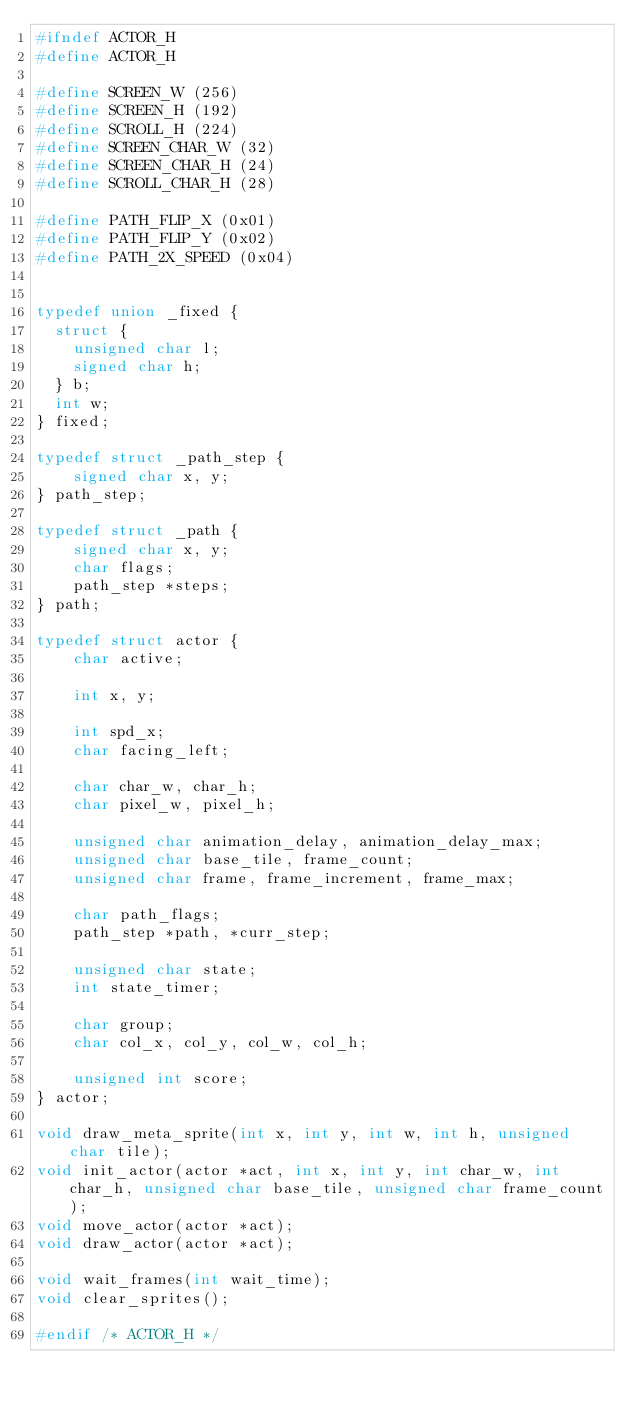<code> <loc_0><loc_0><loc_500><loc_500><_C_>#ifndef ACTOR_H
#define ACTOR_H

#define SCREEN_W (256)
#define SCREEN_H (192)
#define SCROLL_H (224)
#define SCREEN_CHAR_W (32)
#define SCREEN_CHAR_H (24)
#define SCROLL_CHAR_H (28)

#define PATH_FLIP_X (0x01)
#define PATH_FLIP_Y (0x02)
#define PATH_2X_SPEED (0x04)


typedef union _fixed {
  struct {
    unsigned char l;
    signed char h;
  } b;
  int w;
} fixed;

typedef struct _path_step {
	signed char x, y;
} path_step;

typedef struct _path {
	signed char x, y;
	char flags;
	path_step *steps;
} path;

typedef struct actor {
	char active;
	
	int x, y;
	
	int spd_x;
	char facing_left;
	
	char char_w, char_h;
	char pixel_w, pixel_h;
	
	unsigned char animation_delay, animation_delay_max;
	unsigned char base_tile, frame_count;
	unsigned char frame, frame_increment, frame_max;
	
	char path_flags;
	path_step *path, *curr_step;
	
	unsigned char state;
	int state_timer;
	
	char group;
	char col_x, col_y, col_w, col_h;
	
	unsigned int score;
} actor;

void draw_meta_sprite(int x, int y, int w, int h, unsigned char tile);
void init_actor(actor *act, int x, int y, int char_w, int char_h, unsigned char base_tile, unsigned char frame_count);
void move_actor(actor *act);
void draw_actor(actor *act);

void wait_frames(int wait_time);
void clear_sprites();

#endif /* ACTOR_H */</code> 